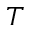<formula> <loc_0><loc_0><loc_500><loc_500>T</formula> 